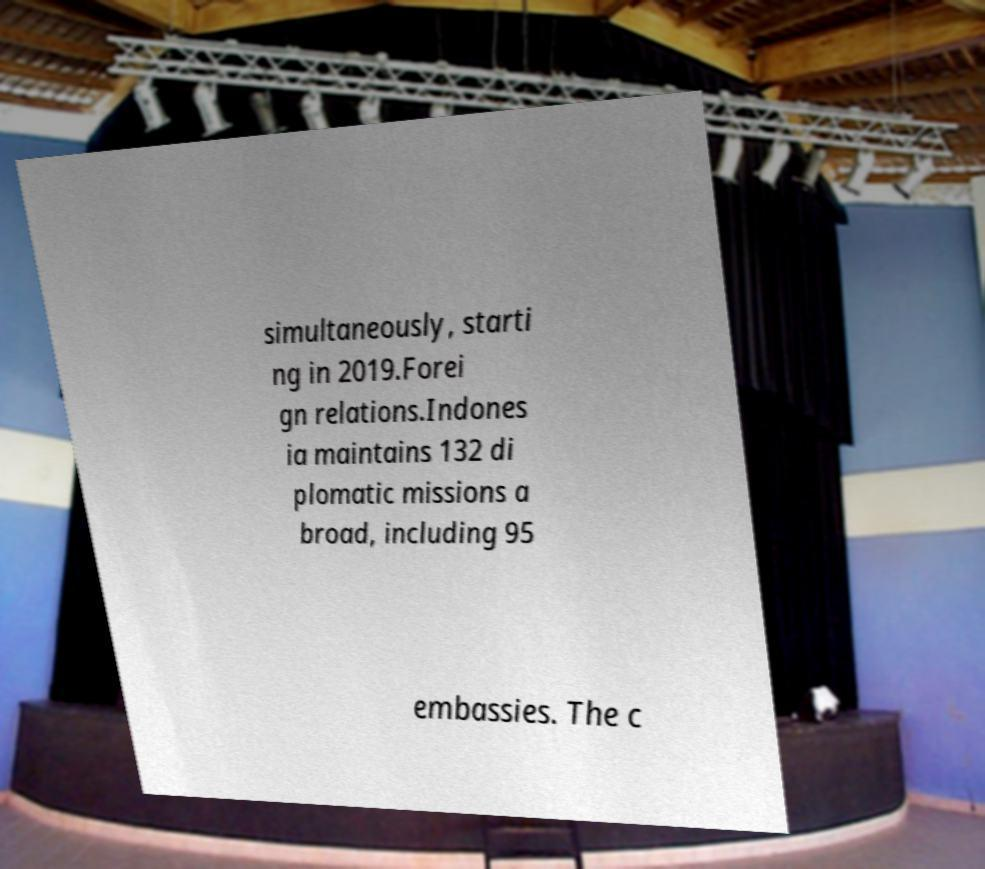For documentation purposes, I need the text within this image transcribed. Could you provide that? simultaneously, starti ng in 2019.Forei gn relations.Indones ia maintains 132 di plomatic missions a broad, including 95 embassies. The c 